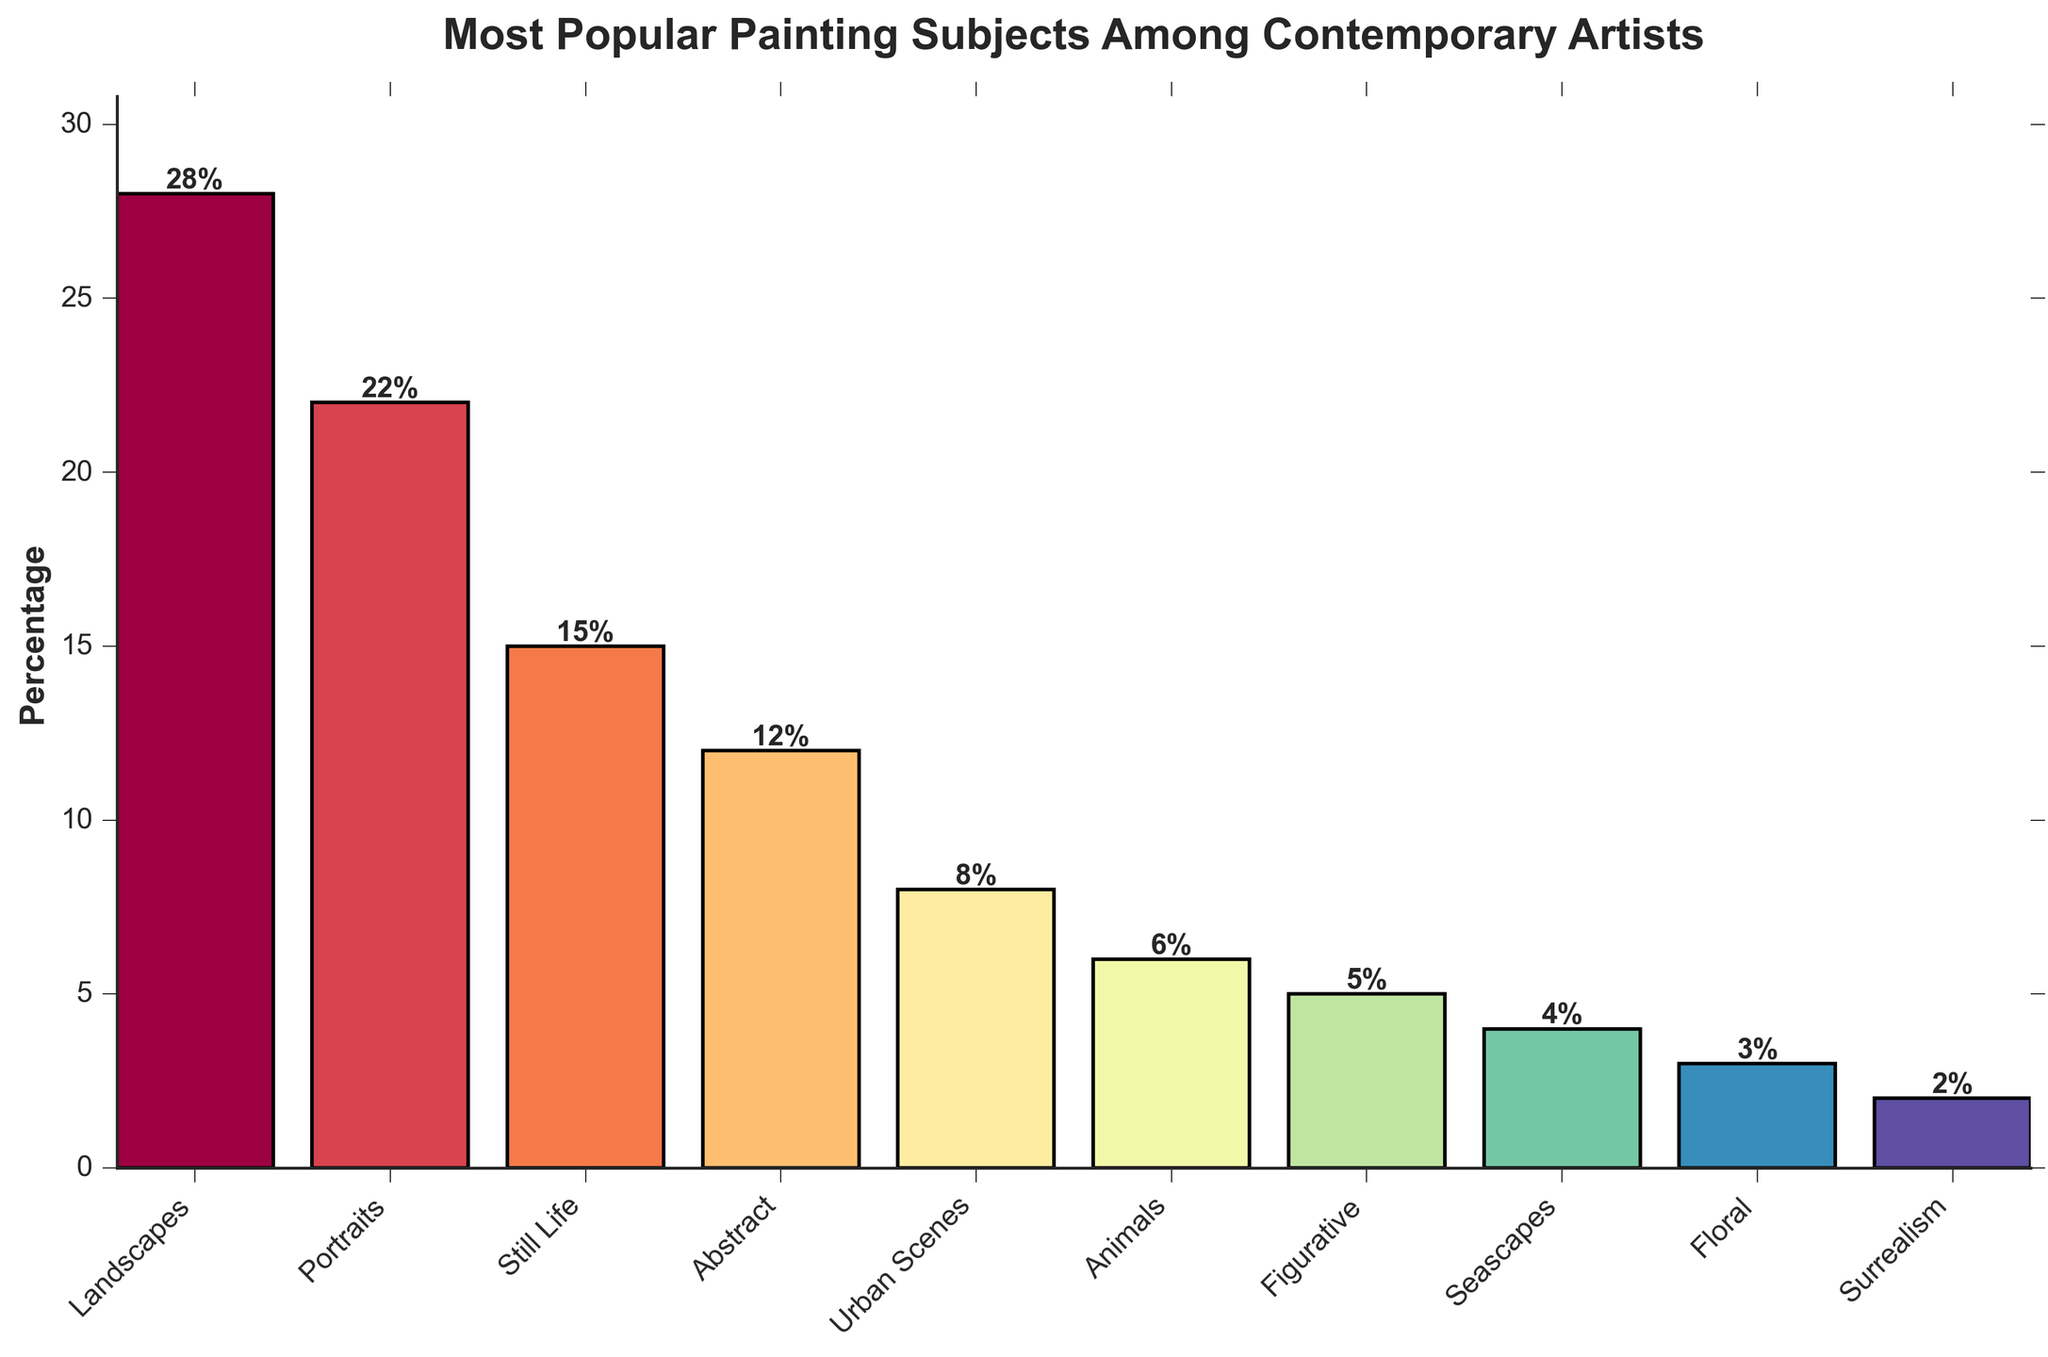What is the most popular painting subject among contemporary artists? The highest bar represents the most popular subject. From the bar chart, the tallest bar is for Landscapes.
Answer: Landscapes Which subject has the least popularity among contemporary artists? The shortest bar indicates the least popular subject. From the chart, Surrealism has the shortest bar.
Answer: Surrealism How much more popular are Landscapes compared to Seascapes? Subtract the percentage of Seascapes from the percentage of Landscapes. Landscapes have 28%, and Seascapes have 4%. So, 28% - 4% = 24%.
Answer: 24% What is the combined popularity percentage of Portraits and Still Life? Add the percentages of Portraits and Still Life. Portraits have 22%, and Still Life has 15%. So, 22% + 15% = 37%.
Answer: 37% Which two subjects have the closest popularity percentages? Look for bars with similar heights. Abstract (12%) and Urban Scenes (8%) are not the closest. Portraits (22%) and Still Life (15%) are also not the closest. Figural (5%) and Seascapes (4%) are the closest. They differ by only 1%.
Answer: Figural and Seascapes Is Abstract painting more popular than Urban Scenes? Compare the heights of the two bars. Abstract has 12% and Urban Scenes have 8%. Since 12% is greater than 8%, Abstract is more popular.
Answer: Yes What is the average popularity percentage of all the painting subjects? Sum the percentages of all subjects and divide by the number of subjects. (28 + 22 + 15 + 12 + 8 + 6 + 5 + 4 + 3 + 2) = 105. Divide by the number of subjects, which is 10. So, 105 / 10 = 10.5%.
Answer: 10.5% Which subjects together constitute exactly 50% of the popularity? Look for a combination of subjects where the sum of their percentages equals 50%. Portraits (22%) + Still Life (15%) + Urban Scenes (8%) + Animals (6%) = 51% which is not 50%. Landscapes (28%) + Portraits (22%) = 50%.
Answer: Landscapes and Portraits What is the total percentage of subjects that are less popular than Abstract painting? Sum the percentages of subjects with a lower percentage than Abstract (12%). Urban Scenes (8%) + Animals (6%) + Figurative (5%) + Seascapes (4%) + Floral (3%) + Surrealism (2%) = 28%.
Answer: 28% Are Portraits more popular than both Abstract and Still Life combined? Compare the percentage of Portraits with the combined percentage of Abstract and Still Life. Portraits have 22%. Abstract (12%) + Still Life (15%) = 27%. Since 27% is greater than 22%, Portraits are not more popular.
Answer: No 